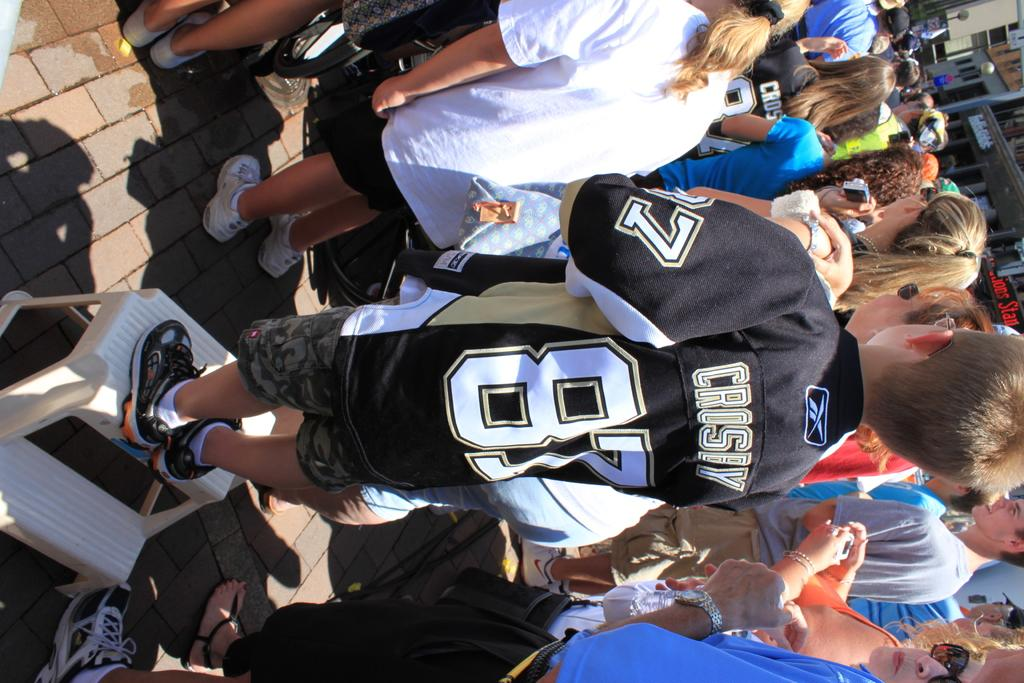Provide a one-sentence caption for the provided image. A young person is wearing a jersey with the name Crosby on the back. 